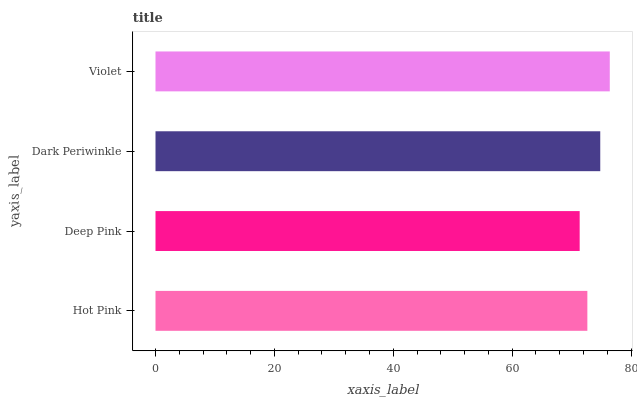Is Deep Pink the minimum?
Answer yes or no. Yes. Is Violet the maximum?
Answer yes or no. Yes. Is Dark Periwinkle the minimum?
Answer yes or no. No. Is Dark Periwinkle the maximum?
Answer yes or no. No. Is Dark Periwinkle greater than Deep Pink?
Answer yes or no. Yes. Is Deep Pink less than Dark Periwinkle?
Answer yes or no. Yes. Is Deep Pink greater than Dark Periwinkle?
Answer yes or no. No. Is Dark Periwinkle less than Deep Pink?
Answer yes or no. No. Is Dark Periwinkle the high median?
Answer yes or no. Yes. Is Hot Pink the low median?
Answer yes or no. Yes. Is Violet the high median?
Answer yes or no. No. Is Dark Periwinkle the low median?
Answer yes or no. No. 